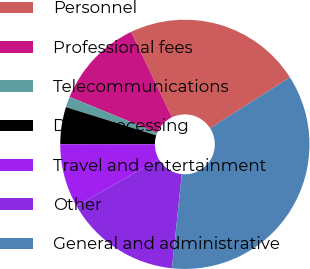Convert chart. <chart><loc_0><loc_0><loc_500><loc_500><pie_chart><fcel>Personnel<fcel>Professional fees<fcel>Telecommunications<fcel>Data processing<fcel>Travel and entertainment<fcel>Other<fcel>General and administrative<nl><fcel>23.06%<fcel>11.68%<fcel>1.39%<fcel>4.82%<fcel>8.25%<fcel>15.11%<fcel>35.68%<nl></chart> 